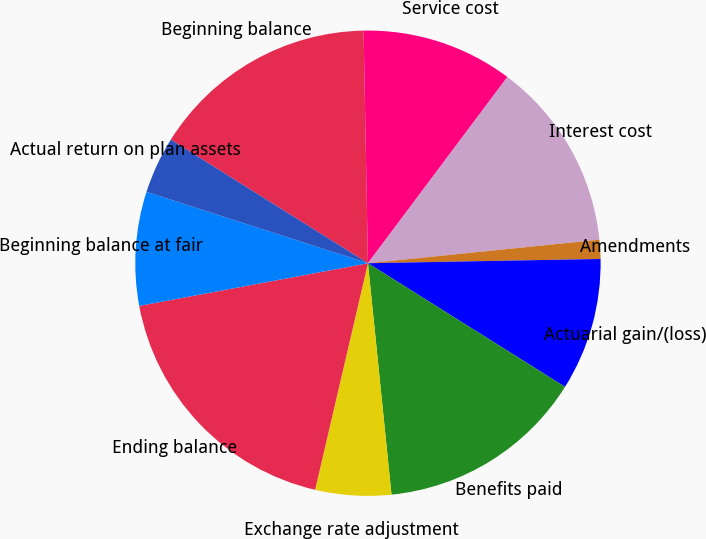Convert chart. <chart><loc_0><loc_0><loc_500><loc_500><pie_chart><fcel>Beginning balance<fcel>Service cost<fcel>Interest cost<fcel>Amendments<fcel>Actuarial gain/(loss)<fcel>Benefits paid<fcel>Exchange rate adjustment<fcel>Ending balance<fcel>Beginning balance at fair<fcel>Actual return on plan assets<nl><fcel>15.79%<fcel>10.53%<fcel>13.16%<fcel>1.32%<fcel>9.21%<fcel>14.47%<fcel>5.26%<fcel>18.42%<fcel>7.9%<fcel>3.95%<nl></chart> 